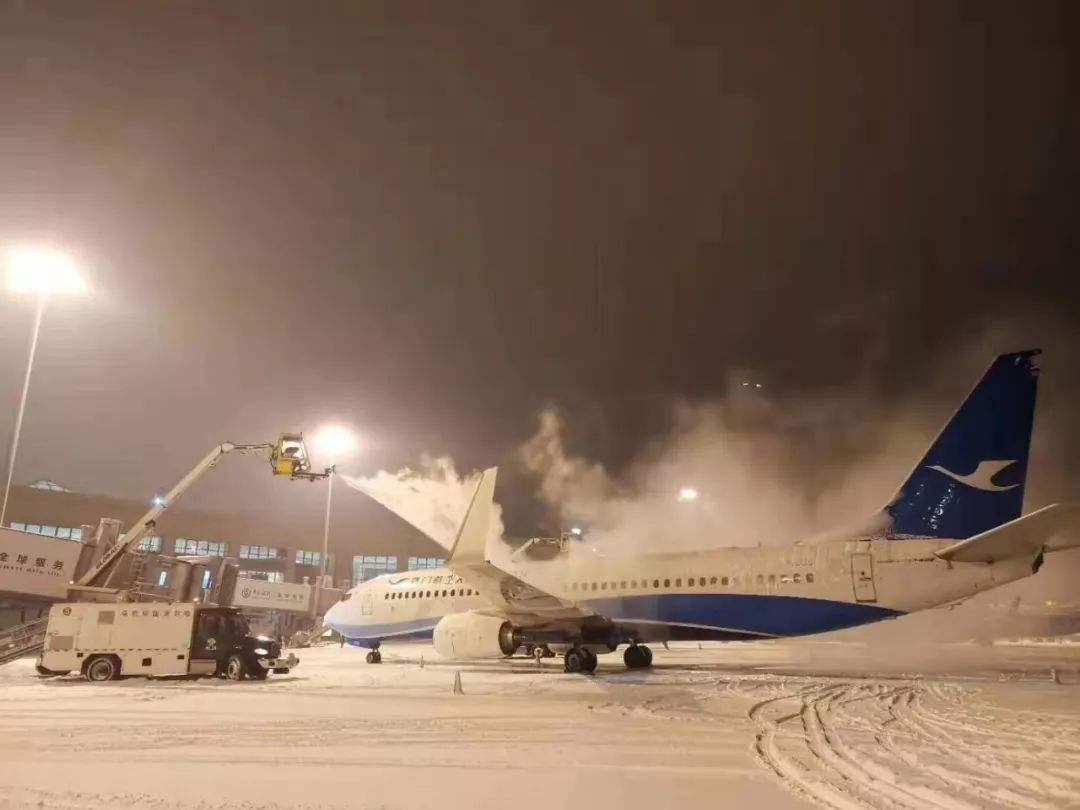What time of day does this image likely represent, and how can you tell? The image likely represents nighttime due to the artificial lighting seen in the photograph, with light fixtures actively illuminating the scene. The darkness of the sky further supports this assessment, as it lacks any visible natural light that would indicate daytime or twilight hours. 